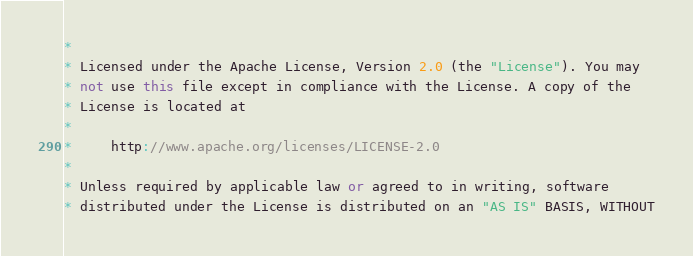Convert code to text. <code><loc_0><loc_0><loc_500><loc_500><_C++_>*
* Licensed under the Apache License, Version 2.0 (the "License"). You may
* not use this file except in compliance with the License. A copy of the
* License is located at
*
*     http://www.apache.org/licenses/LICENSE-2.0
*
* Unless required by applicable law or agreed to in writing, software
* distributed under the License is distributed on an "AS IS" BASIS, WITHOUT</code> 